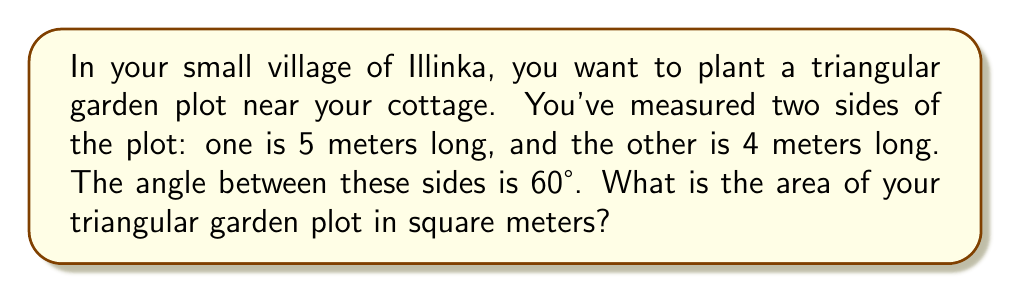What is the answer to this math problem? Let's solve this step-by-step using the trigonometric area formula for triangles:

1) The formula for the area of a triangle given two sides and the included angle is:

   $$A = \frac{1}{2}ab\sin(C)$$

   where $A$ is the area, $a$ and $b$ are the lengths of the two sides, and $C$ is the angle between them.

2) We know:
   $a = 5$ meters
   $b = 4$ meters
   $C = 60°$

3) Let's substitute these values into our formula:

   $$A = \frac{1}{2} \cdot 5 \cdot 4 \cdot \sin(60°)$$

4) We know that $\sin(60°) = \frac{\sqrt{3}}{2}$, so let's substitute this:

   $$A = \frac{1}{2} \cdot 5 \cdot 4 \cdot \frac{\sqrt{3}}{2}$$

5) Now let's simplify:

   $$A = 10 \cdot \frac{\sqrt{3}}{2} = 5\sqrt{3}$$

6) Therefore, the area of the garden plot is $5\sqrt{3}$ square meters.

[asy]
import geometry;

size(100);

pair A=(0,0), B=(5,0), C=(2.5,4.33);
draw(A--B--C--cycle);

label("5m", (A+B)/2, S);
label("4m", (A+C)/2, NW);
label("60°", A, SE);

dot("A", A, SW);
dot("B", B, SE);
dot("C", C, N);
[/asy]
Answer: $5\sqrt{3}$ m² 